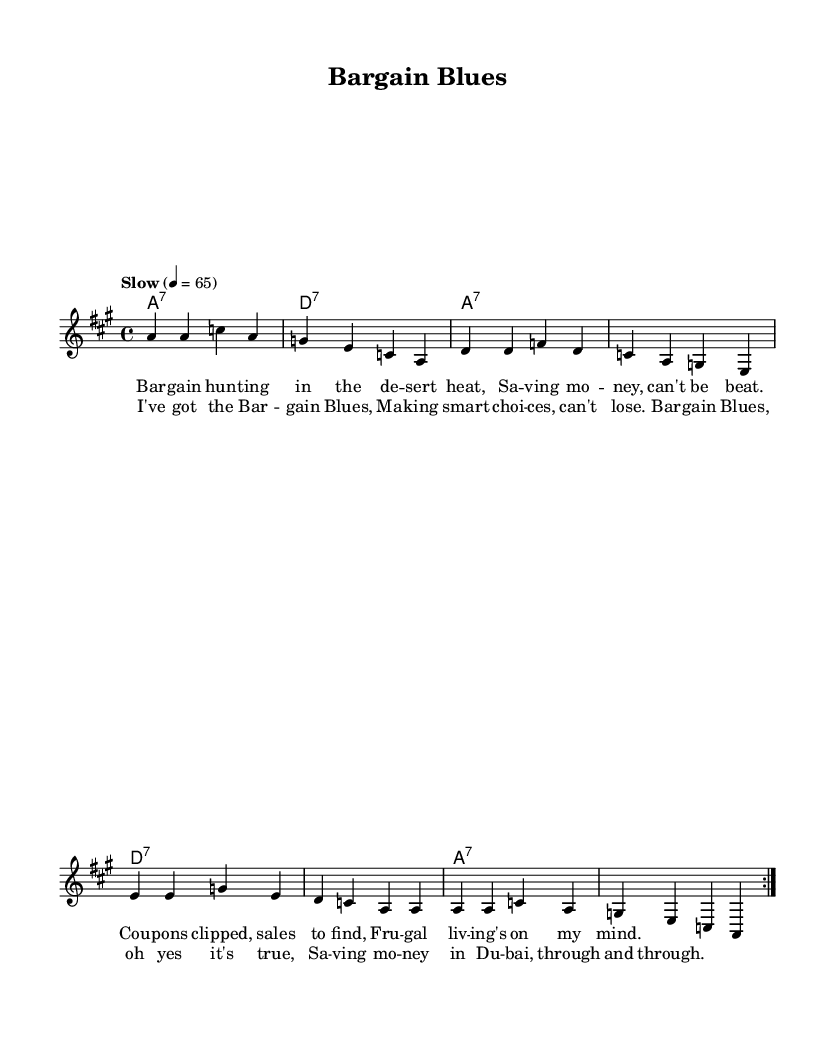What is the key signature of this music? The key signature is A major, identified by three sharps (F#, C#, and G#) shown before the staff in the sheet music.
Answer: A major What is the time signature of this music? The time signature is 4/4, indicated at the beginning of the staff where it shows how many beats are in each measure.
Answer: 4/4 What is the tempo marking for this piece? The tempo marking is "Slow," which instructs the performer to play at a relaxed and unhurried pace, also noted with a metronome marking of 65 beats per minute.
Answer: Slow How many times is the melody repeated in the verse? The melody is repeated two times in the verse, as indicated by the "repeat volta" notation for the respective section of the music.
Answer: 2 What is the first lyric line of the chorus? The first lyric line of the chorus is "I've got the Bargain Blues," which introduces the central theme of the song and aligns with the melody above it.
Answer: I've got the Bargain Blues What musical style does this piece represent? This piece represents the Blues musical style, characterized by its soulful expression and themes celebrating frugality and saving money. The structure and lyrical content also align with traditional Blues.
Answer: Blues What chord precedes the second verse? The chord preceding the second verse is D7, which is indicated within the chord progression shown above the staff in that section.
Answer: D7 